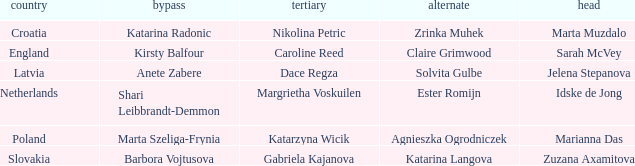Which skip has Zrinka Muhek as Second? Katarina Radonic. 